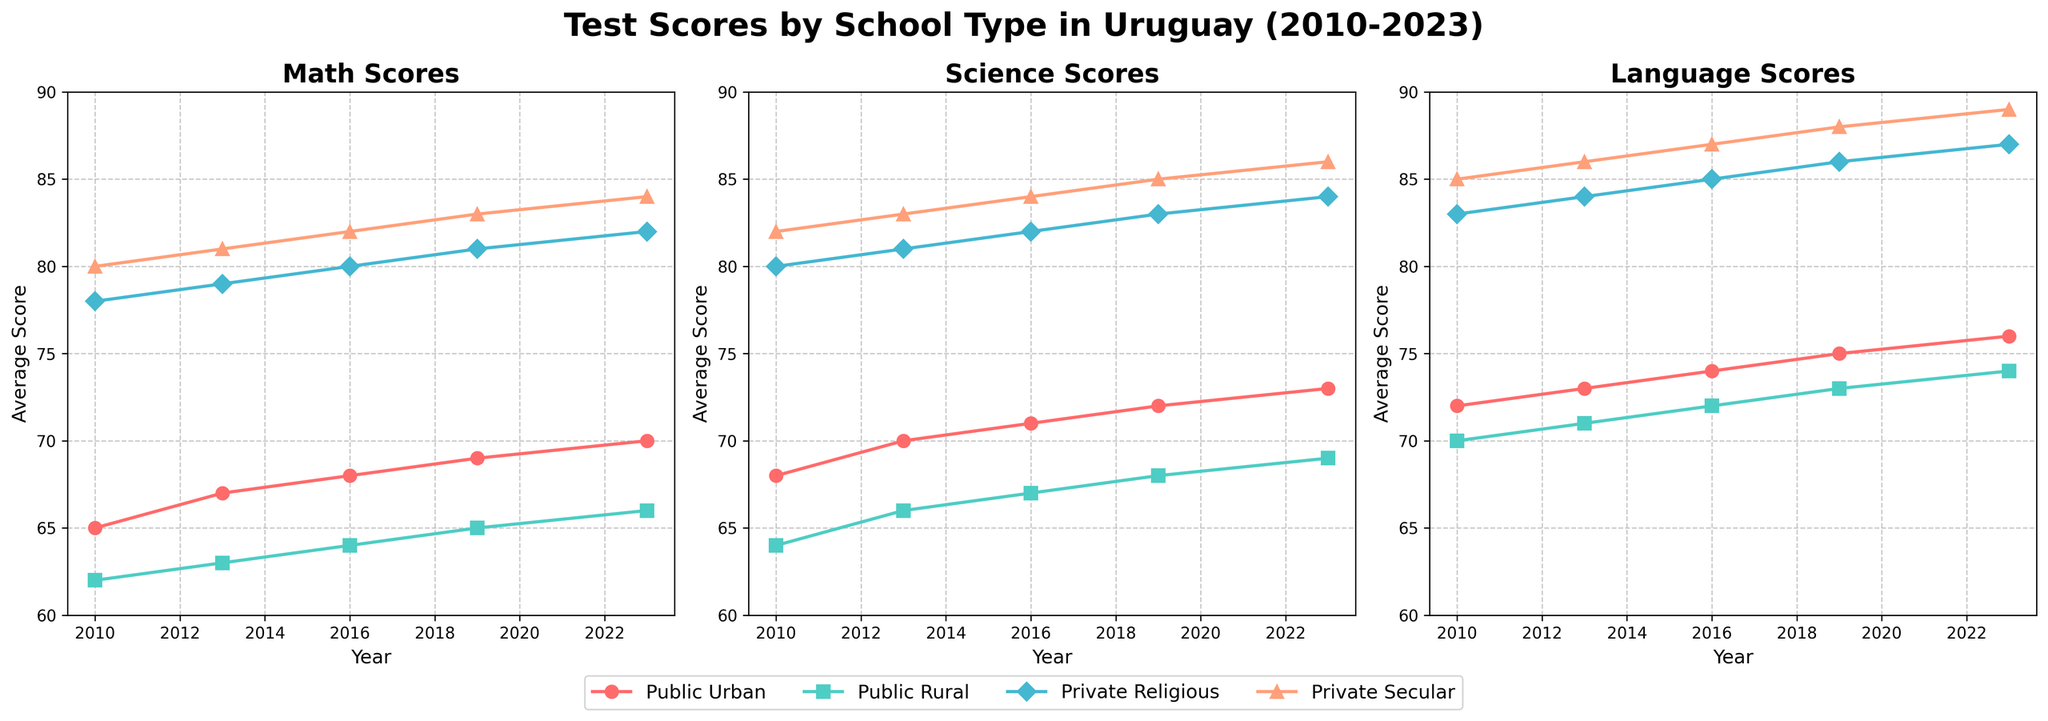What's the average math score for Public Urban schools in 2023? The plot for Math Scores for Public Urban schools in 2023 shows a point with a value of 70. Since we're looking for the average score for a single data point, the average in this case is just the value itself.
Answer: 70 Which school type had the highest science score in 2019? To determine this, look at the science scores in 2019 for each school type. The scores are Public Urban: 72, Public Rural: 68, Private Religious: 83, and Private Secular: 85. The highest score is 85, achieved by Private Secular schools.
Answer: Private Secular How did the language scores for Public Rural schools change from 2010 to 2023? Review the language scores for Public Rural schools in 2010 (70) and 2023 (74). The change in scores can be calculated by subtracting the 2010 score from the 2023 score (74 - 70), resulting in an increase of 4 points.
Answer: Increased by 4 points What year did Public Urban schools have their lowest math score? To find the year with the lowest math score for Public Urban schools, compare the values for 2010 (65), 2013 (67), 2016 (68), 2019 (69), and 2023 (70). The lowest score is 65, which occurred in 2010.
Answer: 2010 Compare the trend in science scores between Private Religious and Private Secular schools from 2010 to 2023. To compare the trends, observe the science scores for Private Religious and Private Secular schools from 2010 to 2023. The scores for Private Religious are 80, 81, 82, 83, and 84, showing an incremental increase. For Private Secular, the scores are 82, 83, 84, 85, and 86, also showing an incremental increase but consistently higher than the scores of Private Religious. Both trends show an increase, with Private Secular having higher scores throughout the years.
Answer: Both increasing; Private Secular consistently higher Which subject had the most significant improvement in scores for Public Rural schools from 2010 to 2023? Analyze the score changes for Public Rural schools in each subject from 2010 to 2023. Math increased from 62 to 66 (4 points), Science from 64 to 69 (5 points), and Language from 70 to 74 (4 points). The most significant improvement is in Science with an increase of 5 points.
Answer: Science What was the trend in math scores for Private Secular schools between the years 2010 and 2019? Look at the math scores for Private Secular schools from 2010 (80), 2013 (81), 2016 (82), and 2019 (83). There is a consistent upward trend with scores increasing by 1 point in each interval.
Answer: Increasing Which school type had the smallest difference between math and language scores in 2023? Calculate the difference between math and language scores for each school type in 2023: Public Urban (76 - 70 = 6), Public Rural (74 - 66 = 8), Private Religious (87 - 82 = 5), Private Secular (89 - 84 = 5). Both Private Religious and Private Secular schools have the smallest difference of 5 points.
Answer: Private Religious and Private Secular How much higher were the language scores for Private Secular schools compared to Public Rural schools in 2023? Compare the 2023 language scores: Private Secular (89) and Public Rural (74). The difference is 89 - 74 = 15.
Answer: 15 points higher What is the overall trend in language scores for Private Religious schools from 2010 to 2023? The language scores for Private Religious schools from 2010 to 2023 are 83, 84, 85, 86, and 87. The scores show a consistent upward trend over the years.
Answer: Increasing 